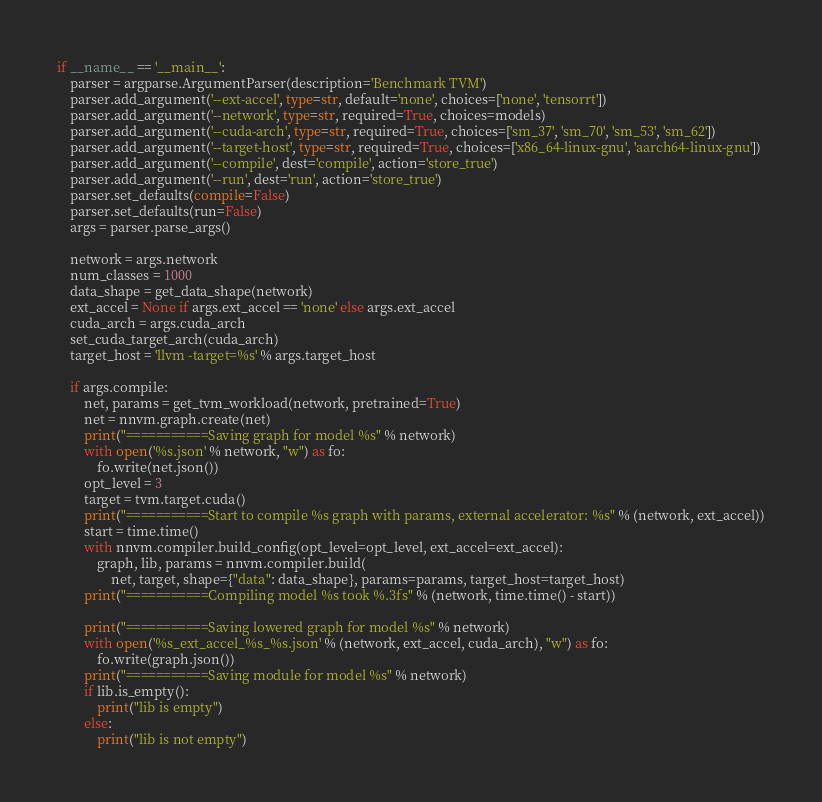Convert code to text. <code><loc_0><loc_0><loc_500><loc_500><_Python_>if __name__ == '__main__':
    parser = argparse.ArgumentParser(description='Benchmark TVM')
    parser.add_argument('--ext-accel', type=str, default='none', choices=['none', 'tensorrt'])
    parser.add_argument('--network', type=str, required=True, choices=models)
    parser.add_argument('--cuda-arch', type=str, required=True, choices=['sm_37', 'sm_70', 'sm_53', 'sm_62'])
    parser.add_argument('--target-host', type=str, required=True, choices=['x86_64-linux-gnu', 'aarch64-linux-gnu'])
    parser.add_argument('--compile', dest='compile', action='store_true')
    parser.add_argument('--run', dest='run', action='store_true')
    parser.set_defaults(compile=False)
    parser.set_defaults(run=False)
    args = parser.parse_args()

    network = args.network
    num_classes = 1000
    data_shape = get_data_shape(network)
    ext_accel = None if args.ext_accel == 'none' else args.ext_accel
    cuda_arch = args.cuda_arch
    set_cuda_target_arch(cuda_arch)
    target_host = 'llvm -target=%s' % args.target_host

    if args.compile:
        net, params = get_tvm_workload(network, pretrained=True)
        net = nnvm.graph.create(net)
        print("===========Saving graph for model %s" % network)
        with open('%s.json' % network, "w") as fo:
            fo.write(net.json())
        opt_level = 3
        target = tvm.target.cuda()
        print("===========Start to compile %s graph with params, external accelerator: %s" % (network, ext_accel))
        start = time.time()
        with nnvm.compiler.build_config(opt_level=opt_level, ext_accel=ext_accel):
            graph, lib, params = nnvm.compiler.build(
                net, target, shape={"data": data_shape}, params=params, target_host=target_host)
        print("===========Compiling model %s took %.3fs" % (network, time.time() - start))

        print("===========Saving lowered graph for model %s" % network)
        with open('%s_ext_accel_%s_%s.json' % (network, ext_accel, cuda_arch), "w") as fo:
            fo.write(graph.json())
        print("===========Saving module for model %s" % network)
        if lib.is_empty():
            print("lib is empty")
        else:
            print("lib is not empty")</code> 